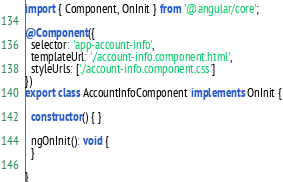Convert code to text. <code><loc_0><loc_0><loc_500><loc_500><_TypeScript_>import { Component, OnInit } from '@angular/core';

@Component({
  selector: 'app-account-info',
  templateUrl: './account-info.component.html',
  styleUrls: ['./account-info.component.css']
})
export class AccountInfoComponent implements OnInit {

  constructor() { }

  ngOnInit(): void {
  }

}
</code> 